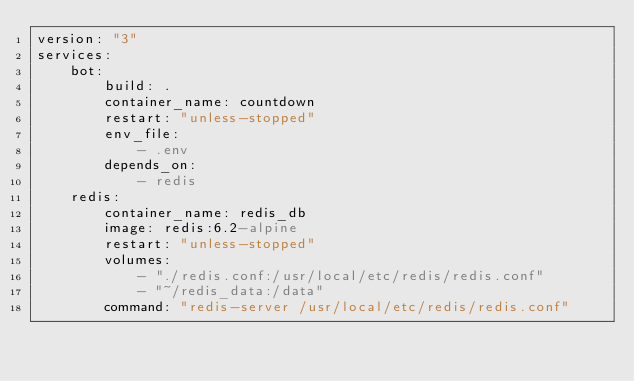Convert code to text. <code><loc_0><loc_0><loc_500><loc_500><_YAML_>version: "3"
services:
    bot:
        build: .
        container_name: countdown
        restart: "unless-stopped"
        env_file:
            - .env
        depends_on:
            - redis
    redis:
        container_name: redis_db
        image: redis:6.2-alpine
        restart: "unless-stopped"
        volumes:
            - "./redis.conf:/usr/local/etc/redis/redis.conf"
            - "~/redis_data:/data"
        command: "redis-server /usr/local/etc/redis/redis.conf"
</code> 